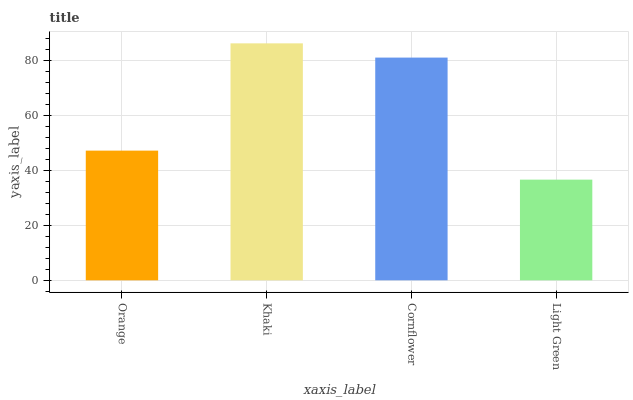Is Light Green the minimum?
Answer yes or no. Yes. Is Khaki the maximum?
Answer yes or no. Yes. Is Cornflower the minimum?
Answer yes or no. No. Is Cornflower the maximum?
Answer yes or no. No. Is Khaki greater than Cornflower?
Answer yes or no. Yes. Is Cornflower less than Khaki?
Answer yes or no. Yes. Is Cornflower greater than Khaki?
Answer yes or no. No. Is Khaki less than Cornflower?
Answer yes or no. No. Is Cornflower the high median?
Answer yes or no. Yes. Is Orange the low median?
Answer yes or no. Yes. Is Orange the high median?
Answer yes or no. No. Is Khaki the low median?
Answer yes or no. No. 